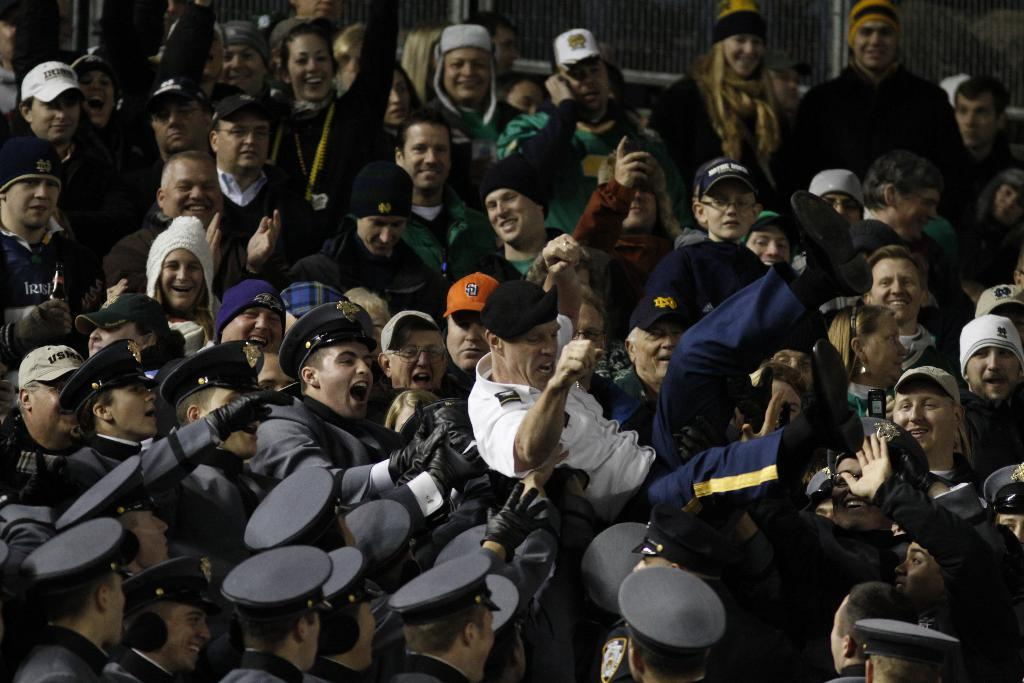How many people are in the image? There is a group of persons in the image, but the exact number is not specified. What are some of the people wearing in the image? Some persons are wearing caps in the image. What are some of the people holding in the image? Some persons are holding an object in the image. What can be seen towards the top of the image? There is a fencing towards the top of the image. Can you tell me how many times the person in the middle of the group sneezes in the image? There is no indication of anyone sneezing in the image, so it cannot be determined. 